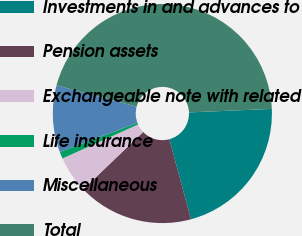Convert chart. <chart><loc_0><loc_0><loc_500><loc_500><pie_chart><fcel>Investments in and advances to<fcel>Pension assets<fcel>Exchangeable note with related<fcel>Life insurance<fcel>Miscellaneous<fcel>Total<nl><fcel>21.46%<fcel>17.05%<fcel>5.43%<fcel>1.02%<fcel>9.85%<fcel>45.18%<nl></chart> 